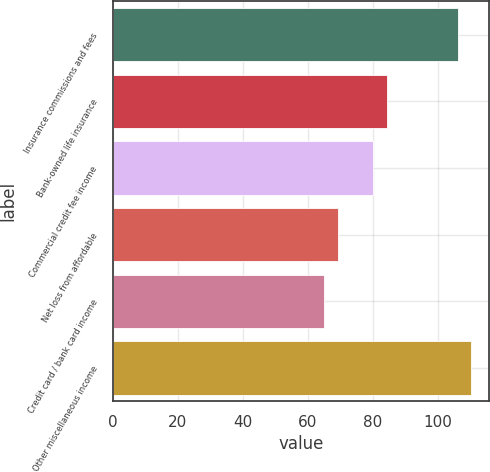Convert chart to OTSL. <chart><loc_0><loc_0><loc_500><loc_500><bar_chart><fcel>Insurance commissions and fees<fcel>Bank-owned life insurance<fcel>Commercial credit fee income<fcel>Net loss from affordable<fcel>Credit card / bank card income<fcel>Other miscellaneous income<nl><fcel>106<fcel>84.2<fcel>80<fcel>69.2<fcel>65<fcel>110.2<nl></chart> 